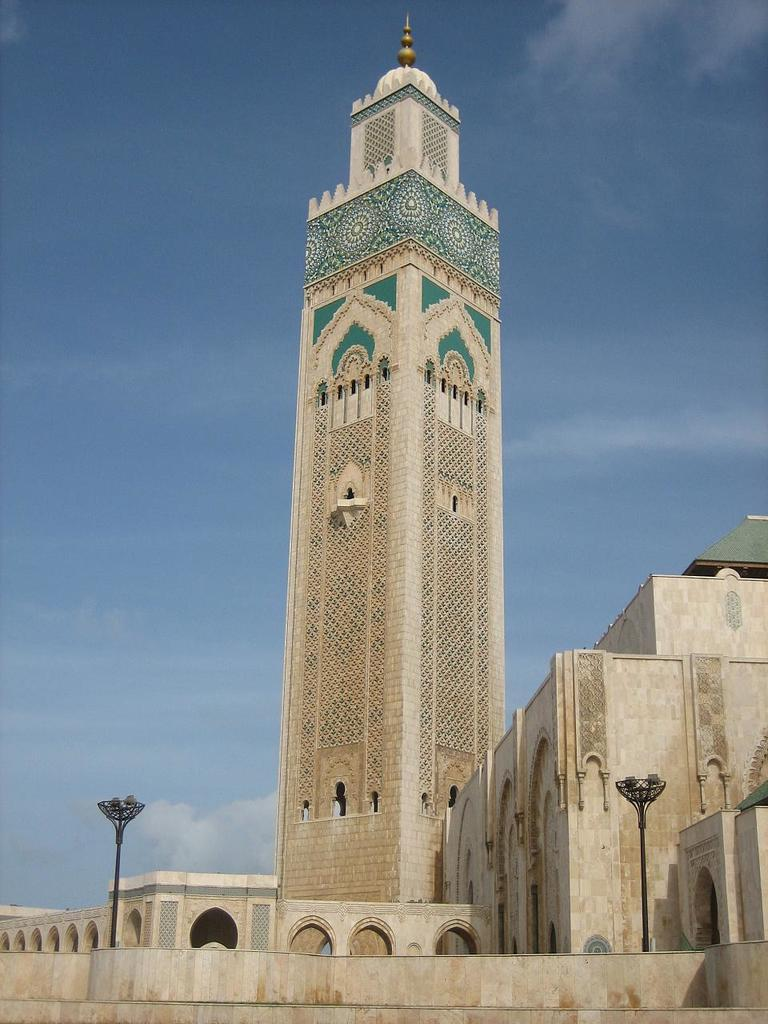What type of building is depicted in the image? The image appears to depict a mosque. What can be seen attached to poles in the image? There are lights attached to poles in the image. What architectural feature is present in the image? There is an arch in the image. What is visible in the background of the image? The sky is visible in the image. What arithmetic problem is being solved by the mosque in the image? There is no arithmetic problem being solved by the mosque in the image. Who is the partner of the mosque in the image? There is no partner present in the image, as the subject is a building and not a person. 